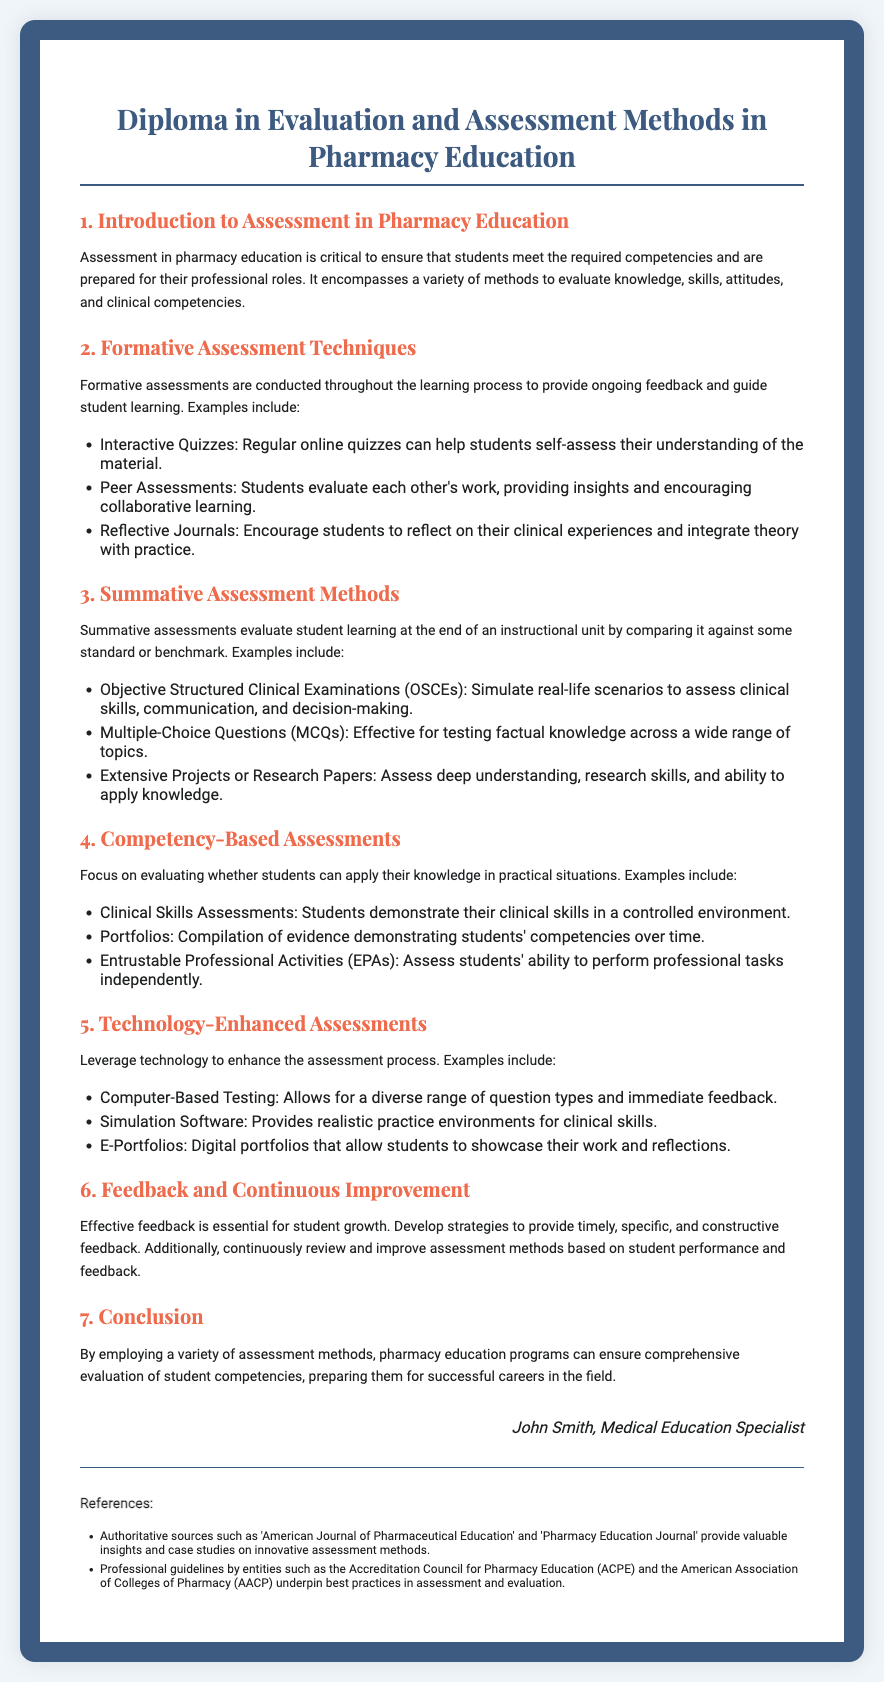what is the title of the diploma? The title of the diploma is clearly stated at the top of the document.
Answer: Diploma in Evaluation and Assessment Methods in Pharmacy Education what are the two types of assessments mentioned in the document? The document lists formative and summative assessments as two main types of assessments in pharmacy education.
Answer: Formative and Summative what assessment technique allows students to reflect on their experiences? The document mentions reflective journals as a technique for students to reflect.
Answer: Reflective Journals which method simulates real-life scenarios to assess clinical skills? The document specifically identifies Objective Structured Clinical Examinations as the method for simulating real-life scenarios.
Answer: Objective Structured Clinical Examinations (OSCEs) what is one technology-enhanced assessment mentioned? The document states that computer-based testing is a technology-enhanced assessment method.
Answer: Computer-Based Testing how many sections are in the diploma? The document outlines six main sections, including the introduction and conclusion.
Answer: Seven what should feedback be described as in the context of assessments? The document emphasizes that effective feedback should be timely, specific, and constructive.
Answer: Timely, Specific, and Constructive who is the author of the diploma? The author's name is mentioned at the end of the document.
Answer: John Smith, Medical Education Specialist what does EPA stand for in competency-based assessments? The acronym EPA is introduced in the section discussing competency-based assessments.
Answer: Entrustable Professional Activities 